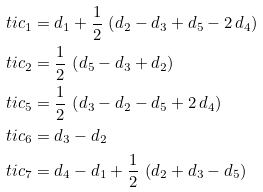Convert formula to latex. <formula><loc_0><loc_0><loc_500><loc_500>\ t i { c } _ { 1 } = & \ d _ { 1 } + \frac { 1 } { 2 } \, \left ( d _ { 2 } - d _ { 3 } + d _ { 5 } - 2 \, d _ { 4 } \right ) \\ \ t i { c } _ { 2 } = & \ \frac { 1 } { 2 } \, \left ( d _ { 5 } - d _ { 3 } + d _ { 2 } \right ) \\ \ t i { c } _ { 5 } = & \ \frac { 1 } { 2 } \, \left ( d _ { 3 } - d _ { 2 } - d _ { 5 } + 2 \, d _ { 4 } \right ) \\ \ t i { c } _ { 6 } = & \ d _ { 3 } - d _ { 2 } \\ \ t i { c } _ { 7 } = & \ d _ { 4 } - d _ { 1 } + \frac { 1 } { 2 } \, \left ( d _ { 2 } + d _ { 3 } - d _ { 5 } \right )</formula> 